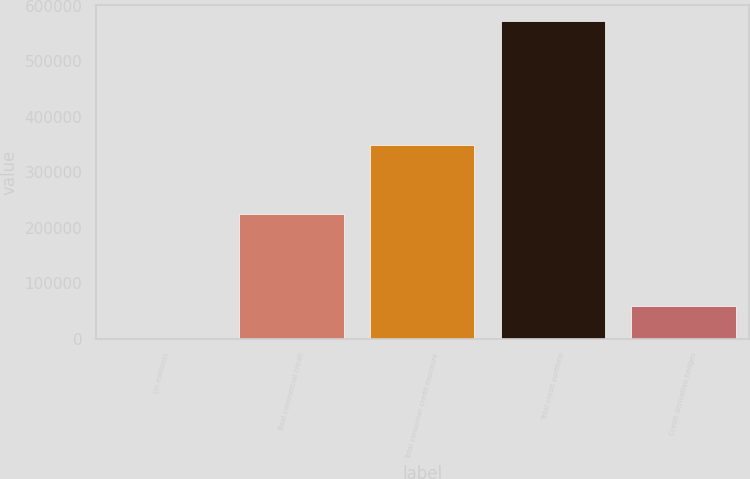Convert chart to OTSL. <chart><loc_0><loc_0><loc_500><loc_500><bar_chart><fcel>(in millions)<fcel>Total commercial credit<fcel>Total consumer credit exposure<fcel>Total credit portfolio<fcel>Credit derivative hedges<nl><fcel>2003<fcel>224207<fcel>348200<fcel>572407<fcel>59043.4<nl></chart> 